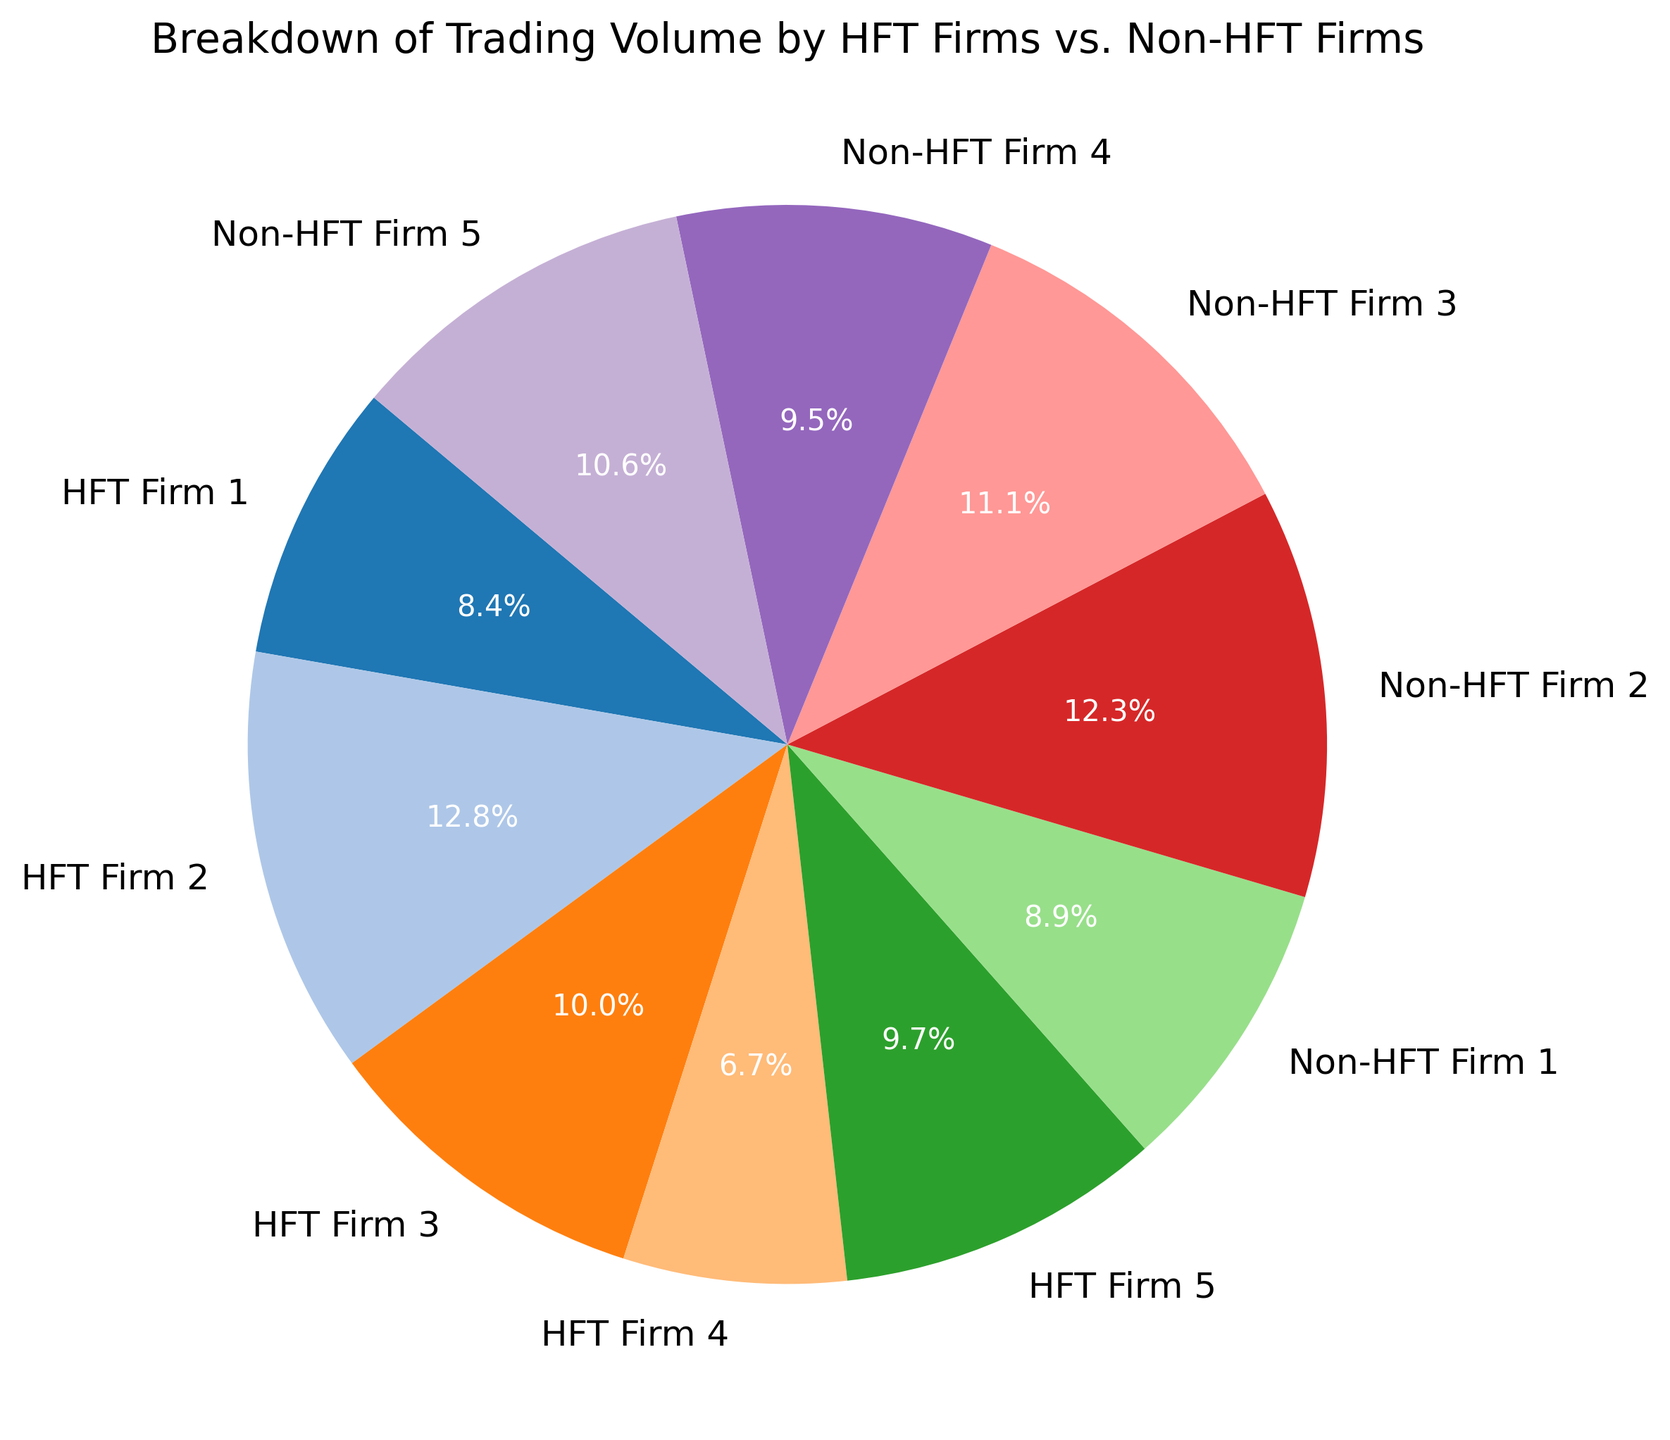Which firm type has the higher total trading volume, HFT firms or Non-HFT firms? By looking at the pie chart, we can see the proportions of trading volume for HFT firms and Non-HFT firms. The chart indicates that the HFT firms collectively have a larger portion of the pie, suggesting a higher total trading volume.
Answer: HFT firms Of the HFT firms, which firm has the smallest trading volume? Inspecting the smaller segments of the pie chart corresponding to HFT firms, we see that HFT Firm 4 has the smallest segment.
Answer: HFT Firm 4 What is the trading volume percentage of Non-HFT Firm 2? We need to identify the segment labeled "Non-HFT Firm 2" in the pie chart and check its percentage, which is indicated by the number next to the segment.
Answer: 22.0% How does the trading volume of HFT Firm 3 compare to that of Non-HFT Firm 3? HFT Firm 3 and Non-HFT Firm 3 are segments in the pie chart. By comparing their sizes visually, we can see that HFT Firm 3 has a smaller segment than Non-HFT Firm 3.
Answer: Smaller What is the total trading volume of the two largest trading firms combined? Identify the two largest segments in the pie chart, which are HFT Firm 2 (2,300,000) and Non-HFT Firm 2 (2,200,000). Summing these values gives 2,300,000 + 2,200,000 = 4,500,000.
Answer: 4,500,000 What is the percentage difference in trading volume between the largest HFT firm and the smallest HFT firm? First, determine the trading volumes: HFT Firm 2 has 2,300,000 and HFT Firm 4 has 1,200,000. Calculate the difference (2,300,000 - 1,200,000 = 1,100,000) and then find the percentage difference relative to the smallest HFT firm (1,100,000 / 1,200,000 * 100%).
Answer: 91.67% Which firm group, HFT or Non-HFT, shows greater diversity in trading volumes? We need to compare the spread of the segments within each group. HFT and Non-HFT firms have visible segments of different sizes, but HFT firms show a wider range of segment sizes, indicating greater diversity.
Answer: HFT firms What is the difference in trading volume between HFT Firm 1 and Non-HFT Firm 1? Locate the segments for HFT Firm 1 (1,500,000) and Non-HFT Firm 1 (1,600,000) in the pie chart. Calculate the difference (1,600,000 - 1,500,000 = 100,000).
Answer: 100,000 Which firm has the third largest trading volume? By visually inspecting the pie chart, identify the third largest segment. The third largest segment is Non-HFT Firm 3.
Answer: Non-HFT Firm 3 